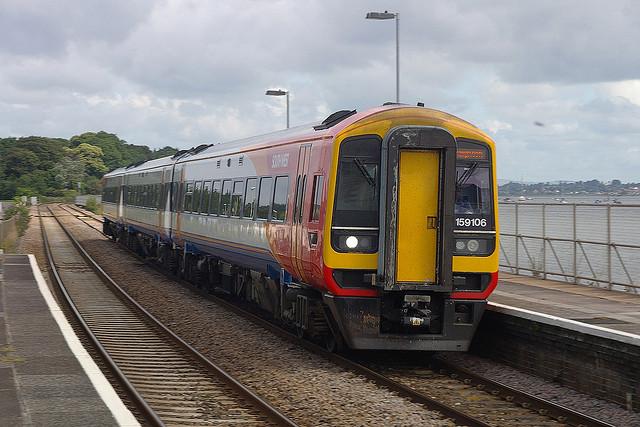Is there water in photo?
Keep it brief. Yes. Is this a train stop?
Keep it brief. No. What color is the train?
Keep it brief. Yellow. What number is on the sign by the platform?
Short answer required. 159106. What numbers are on the train?
Concise answer only. 159106. What color is the front of the train?
Write a very short answer. Yellow. What color are the stripes on the platforms?
Keep it brief. White. Are there a lot of wires?
Give a very brief answer. No. What number is on the train?
Be succinct. 159106. What is along the platform?
Answer briefly. Train. How many trains?
Be succinct. 1. Can you see cones?
Quick response, please. No. 